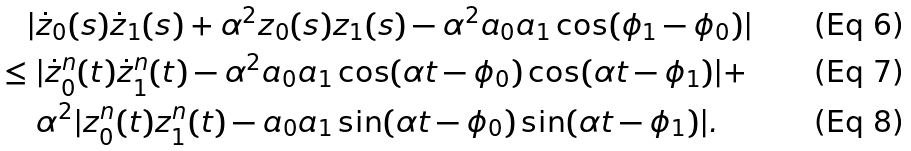<formula> <loc_0><loc_0><loc_500><loc_500>& \quad | \dot { z } _ { 0 } ( s ) \dot { z } _ { 1 } ( s ) + \alpha ^ { 2 } z _ { 0 } ( s ) z _ { 1 } ( s ) - \alpha ^ { 2 } a _ { 0 } a _ { 1 } \cos ( \phi _ { 1 } - \phi _ { 0 } ) | \\ & \leq | \dot { z } ^ { n } _ { 0 } ( t ) \dot { z } ^ { n } _ { 1 } ( t ) - \alpha ^ { 2 } a _ { 0 } a _ { 1 } \cos ( \alpha t - \phi _ { 0 } ) \cos ( \alpha t - \phi _ { 1 } ) | + \\ & \quad \ \alpha ^ { 2 } | z ^ { n } _ { 0 } ( t ) z ^ { n } _ { 1 } ( t ) - a _ { 0 } a _ { 1 } \sin ( \alpha t - \phi _ { 0 } ) \sin ( \alpha t - \phi _ { 1 } ) | .</formula> 